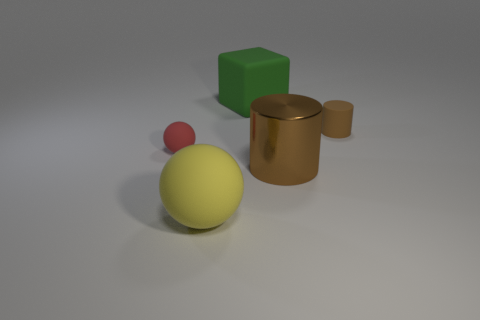Add 4 brown metallic cylinders. How many objects exist? 9 Subtract all cubes. How many objects are left? 4 Add 1 red rubber spheres. How many red rubber spheres are left? 2 Add 1 large objects. How many large objects exist? 4 Subtract 1 yellow spheres. How many objects are left? 4 Subtract all tiny red cylinders. Subtract all tiny brown rubber cylinders. How many objects are left? 4 